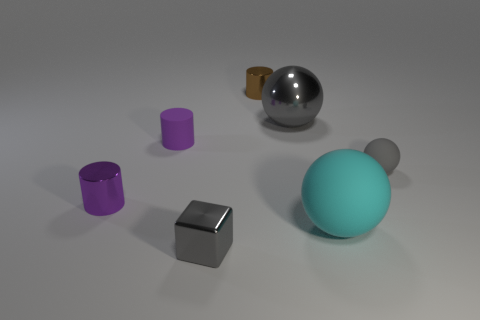What is the size of the gray object that is right of the big shiny sphere? The gray object to the right of the big shiny sphere is small in size, approximately one-quarter of the sphere's diameter. It's a smaller rectangular prism that stands in contrast to the larger spheres around it. 